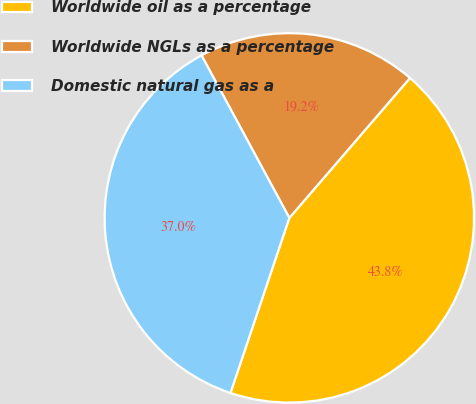Convert chart. <chart><loc_0><loc_0><loc_500><loc_500><pie_chart><fcel>Worldwide oil as a percentage<fcel>Worldwide NGLs as a percentage<fcel>Domestic natural gas as a<nl><fcel>43.84%<fcel>19.21%<fcel>36.95%<nl></chart> 